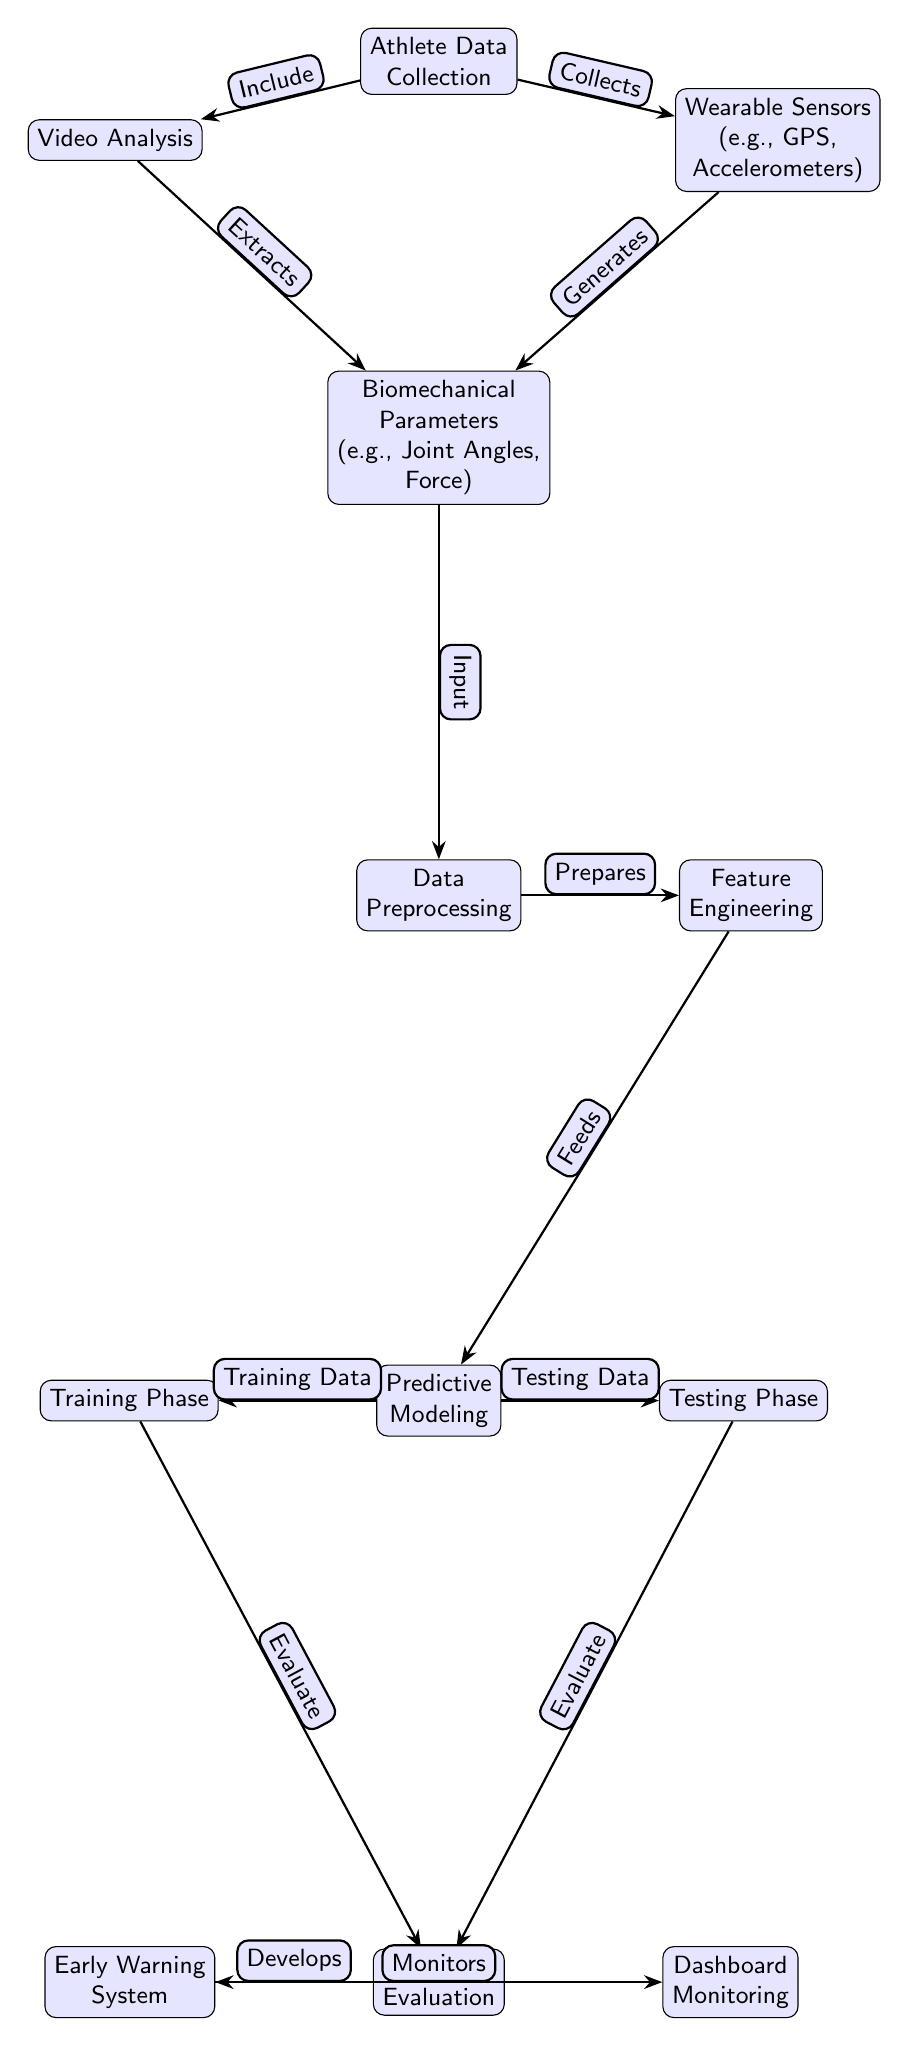What is the first node in the diagram? The first node is "Athlete Data Collection," as it is positioned at the top of the diagram.
Answer: Athlete Data Collection How many edges are present in the diagram? By counting the connections between the nodes, there are a total of 12 edges in the diagram.
Answer: 12 What node generates biomechanical parameters? The "Wearable Sensors" node generates biomechanical parameters. It connects directly to the "Biomechanical Parameters" node.
Answer: Wearable Sensors What are the two phases mentioned in the predictive modeling section? The two phases mentioned are "Training Phase" and "Testing Phase." They branch out from the "Predictive Modeling" node.
Answer: Training Phase, Testing Phase Which node develops the early warning system? The "Model Evaluation" node develops the early warning system as it is the direct source connected to the "Early Warning System" node.
Answer: Model Evaluation What is the function of the "Data Preprocessing" node? The "Data Preprocessing" node prepares the data for the feature engineering process by processing the biomechanical parameters inputted to it.
Answer: Prepares Which node monitors the dashboard? The node that monitors the dashboard is "Dashboard Monitoring," which directly follows the "Early Warning System."
Answer: Dashboard Monitoring What type of data collection includes video analysis? The "Athlete Data Collection" node includes the "Video Analysis," which is indicated as part of the data sources.
Answer: Video Analysis What are biomechanical parameters? Biomechanical parameters are the variables such as joint angles and force that are generated from both wearable sensors and video analysis in the diagram.
Answer: Joint Angles, Force 